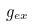Convert formula to latex. <formula><loc_0><loc_0><loc_500><loc_500>g _ { e x }</formula> 